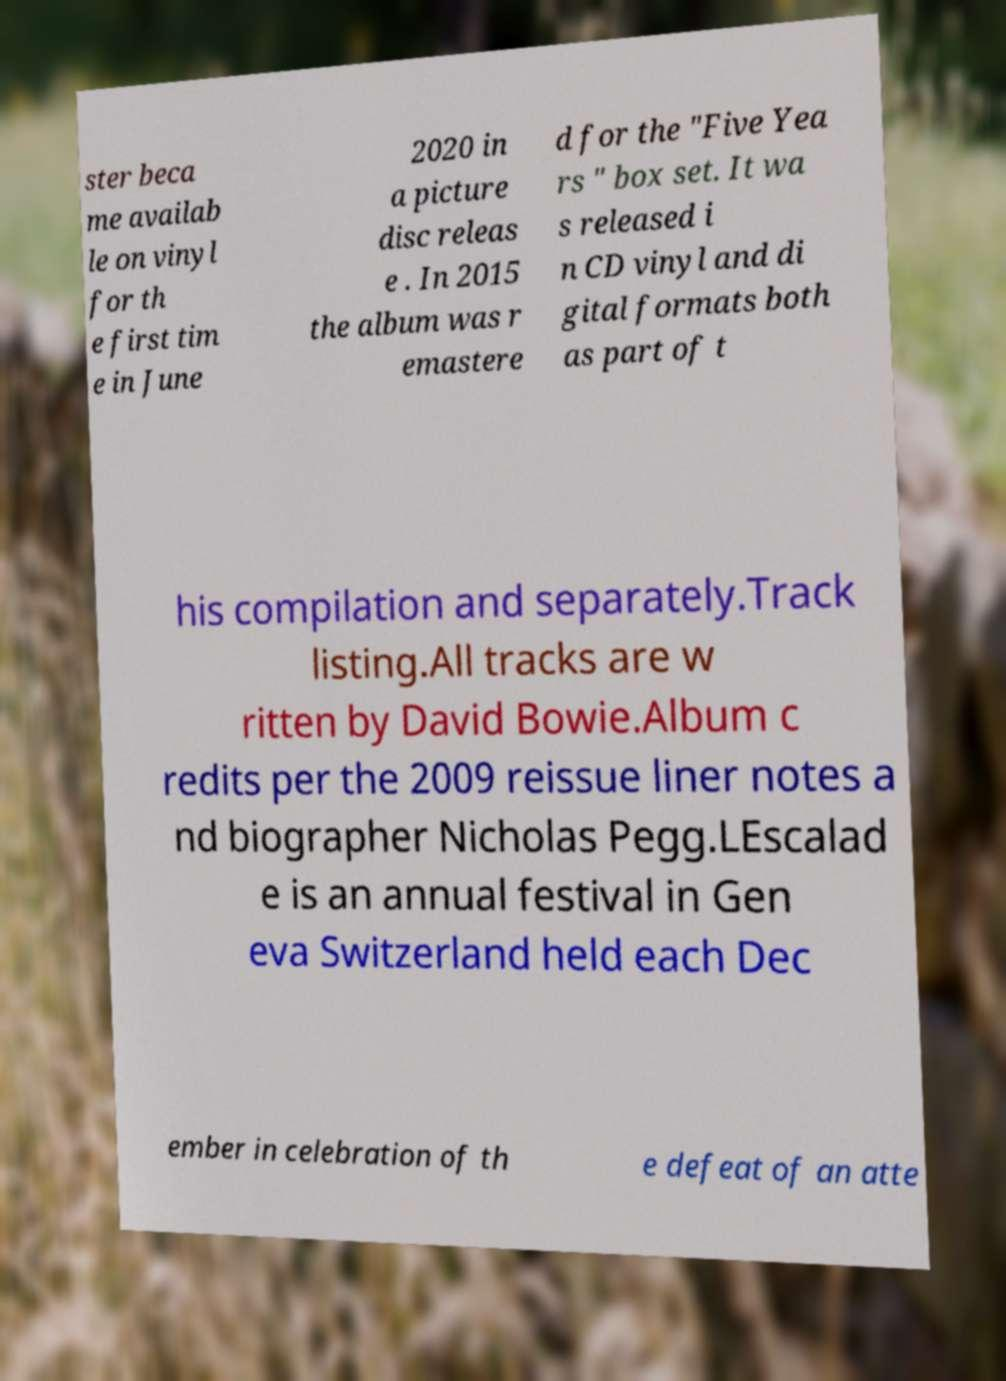There's text embedded in this image that I need extracted. Can you transcribe it verbatim? ster beca me availab le on vinyl for th e first tim e in June 2020 in a picture disc releas e . In 2015 the album was r emastere d for the "Five Yea rs " box set. It wa s released i n CD vinyl and di gital formats both as part of t his compilation and separately.Track listing.All tracks are w ritten by David Bowie.Album c redits per the 2009 reissue liner notes a nd biographer Nicholas Pegg.LEscalad e is an annual festival in Gen eva Switzerland held each Dec ember in celebration of th e defeat of an atte 